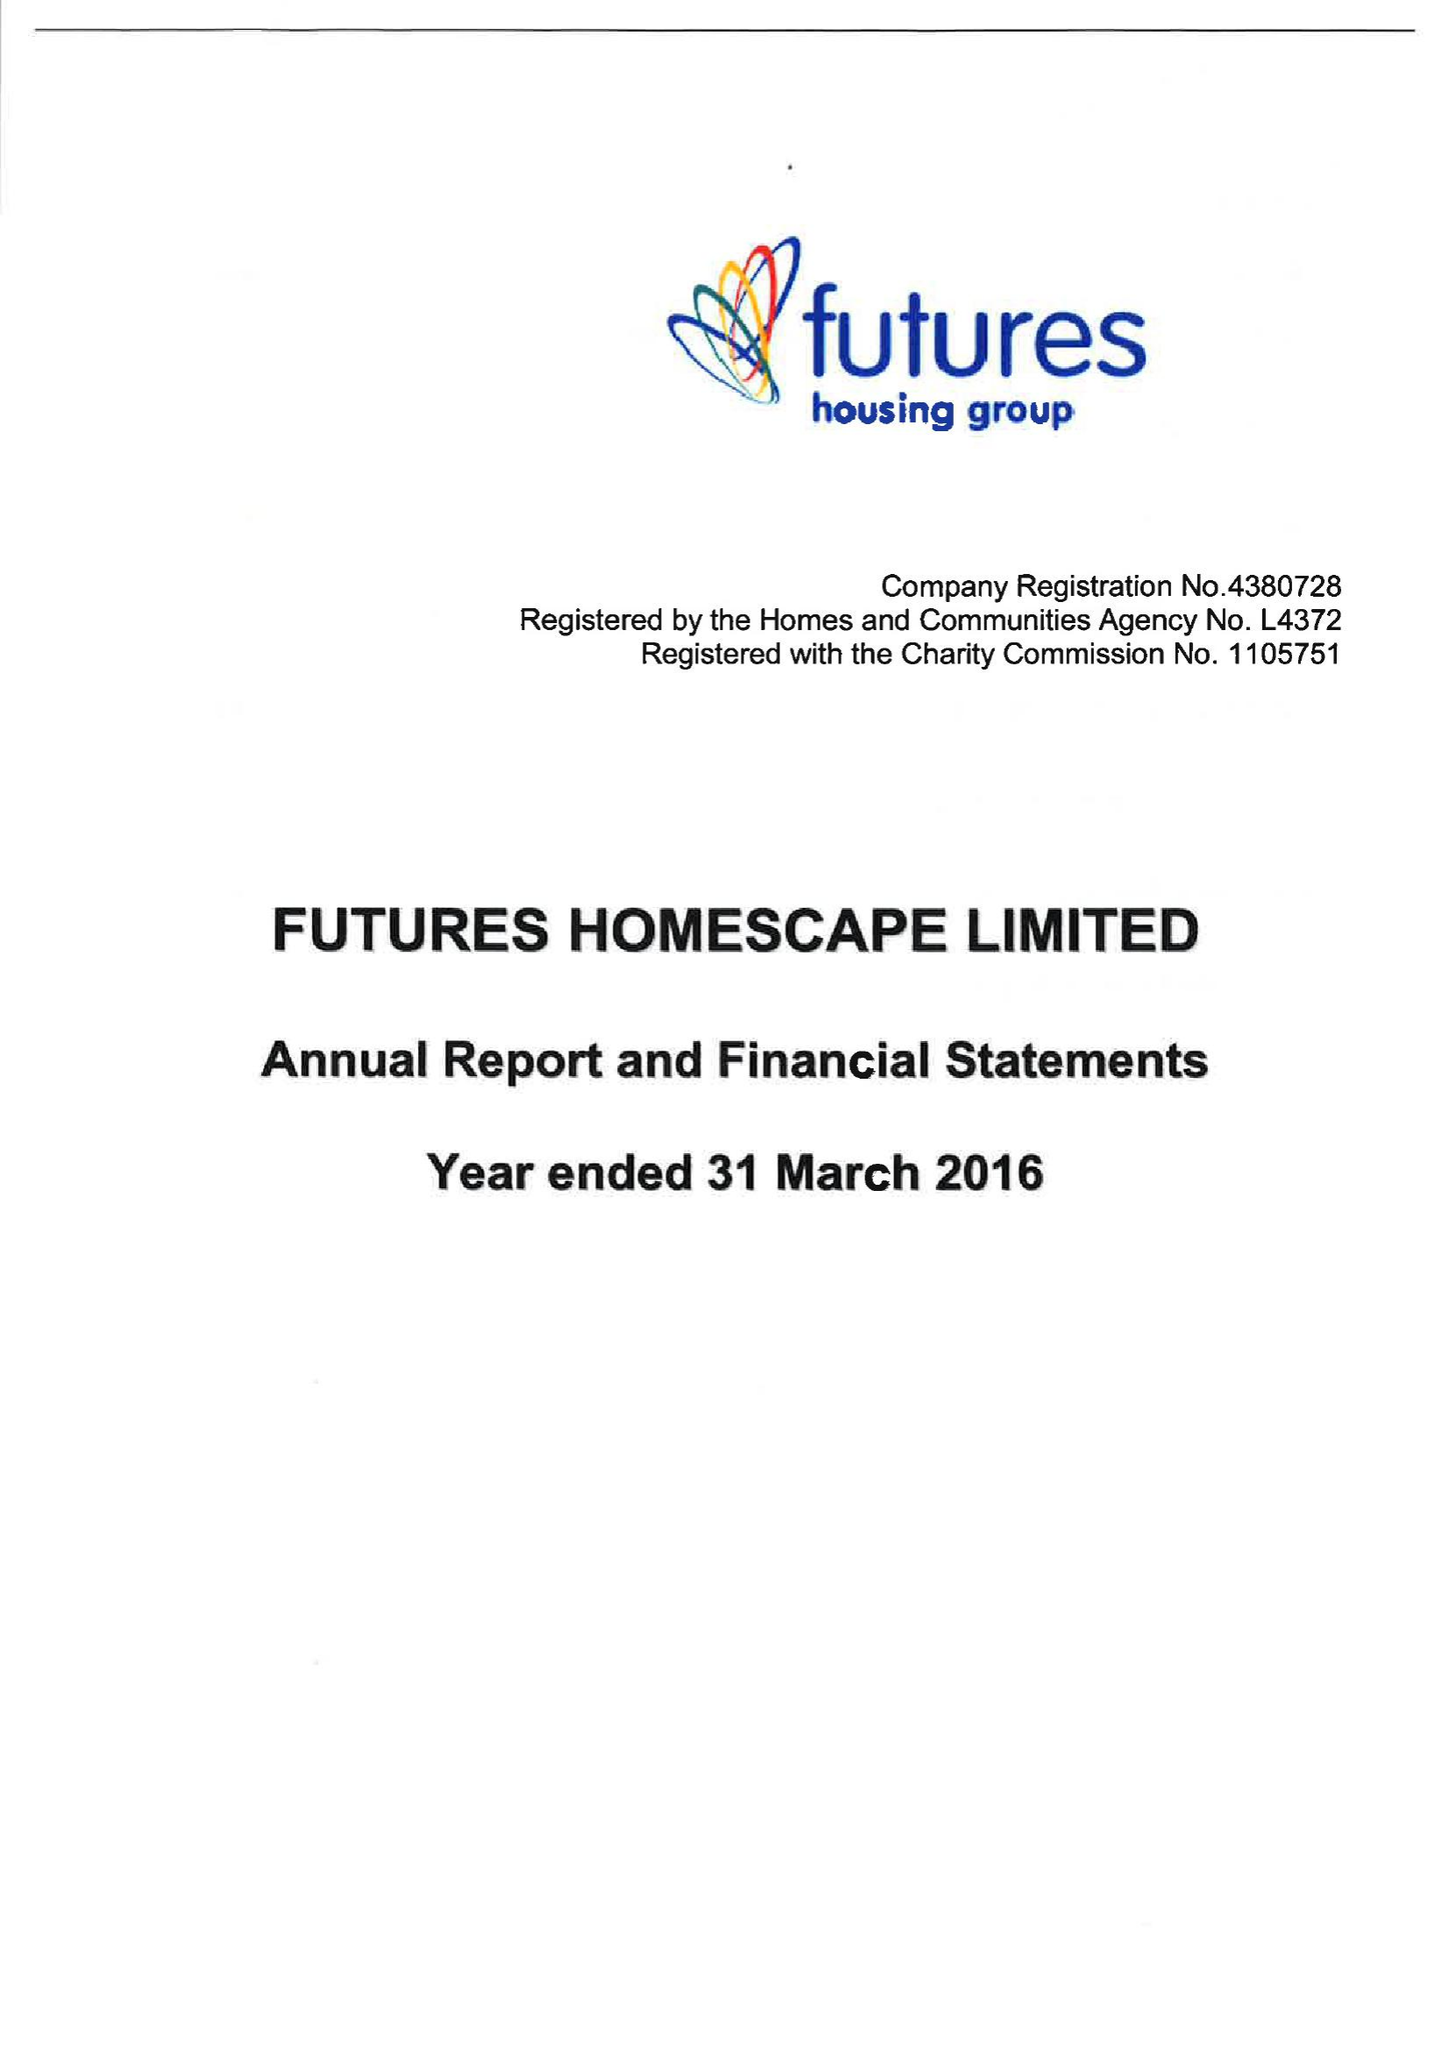What is the value for the spending_annually_in_british_pounds?
Answer the question using a single word or phrase. 24055000.00 